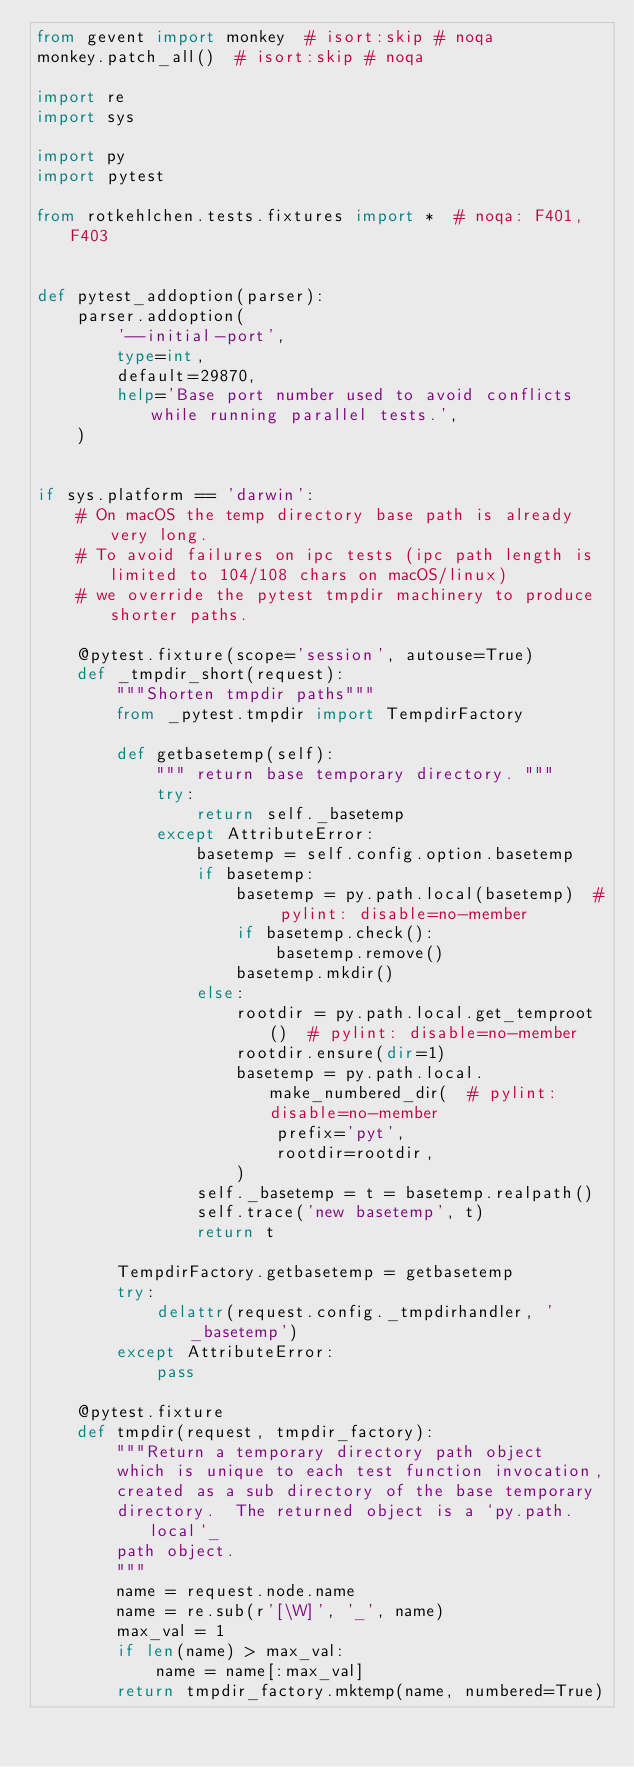Convert code to text. <code><loc_0><loc_0><loc_500><loc_500><_Python_>from gevent import monkey  # isort:skip # noqa
monkey.patch_all()  # isort:skip # noqa

import re
import sys

import py
import pytest

from rotkehlchen.tests.fixtures import *  # noqa: F401,F403


def pytest_addoption(parser):
    parser.addoption(
        '--initial-port',
        type=int,
        default=29870,
        help='Base port number used to avoid conflicts while running parallel tests.',
    )


if sys.platform == 'darwin':
    # On macOS the temp directory base path is already very long.
    # To avoid failures on ipc tests (ipc path length is limited to 104/108 chars on macOS/linux)
    # we override the pytest tmpdir machinery to produce shorter paths.

    @pytest.fixture(scope='session', autouse=True)
    def _tmpdir_short(request):
        """Shorten tmpdir paths"""
        from _pytest.tmpdir import TempdirFactory

        def getbasetemp(self):
            """ return base temporary directory. """
            try:
                return self._basetemp
            except AttributeError:
                basetemp = self.config.option.basetemp
                if basetemp:
                    basetemp = py.path.local(basetemp)  # pylint: disable=no-member
                    if basetemp.check():
                        basetemp.remove()
                    basetemp.mkdir()
                else:
                    rootdir = py.path.local.get_temproot()  # pylint: disable=no-member
                    rootdir.ensure(dir=1)
                    basetemp = py.path.local.make_numbered_dir(  # pylint: disable=no-member
                        prefix='pyt',
                        rootdir=rootdir,
                    )
                self._basetemp = t = basetemp.realpath()
                self.trace('new basetemp', t)
                return t

        TempdirFactory.getbasetemp = getbasetemp
        try:
            delattr(request.config._tmpdirhandler, '_basetemp')
        except AttributeError:
            pass

    @pytest.fixture
    def tmpdir(request, tmpdir_factory):
        """Return a temporary directory path object
        which is unique to each test function invocation,
        created as a sub directory of the base temporary
        directory.  The returned object is a `py.path.local`_
        path object.
        """
        name = request.node.name
        name = re.sub(r'[\W]', '_', name)
        max_val = 1
        if len(name) > max_val:
            name = name[:max_val]
        return tmpdir_factory.mktemp(name, numbered=True)
</code> 